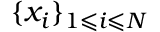<formula> <loc_0><loc_0><loc_500><loc_500>\{ x _ { i } \} _ { 1 \leqslant i \leqslant N }</formula> 